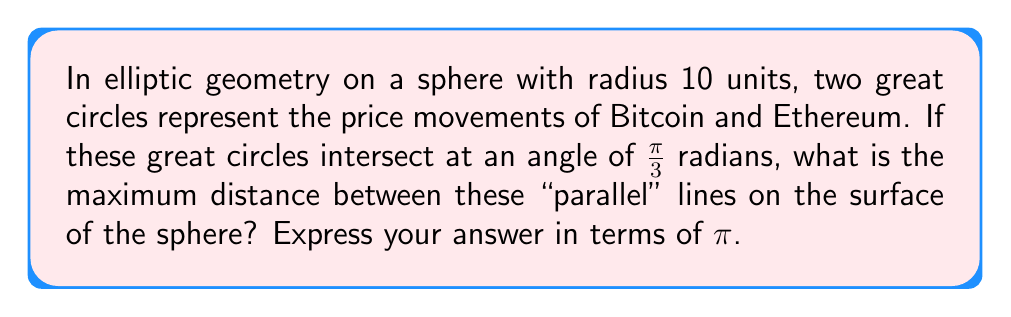Show me your answer to this math problem. Let's approach this step-by-step:

1) In elliptic geometry on a sphere, "parallel" lines are great circles that intersect at two antipodal points.

2) The maximum distance between two great circles occurs at the midpoint between their intersection points.

3) The angle between the great circles at their intersection is given as $\frac{\pi}{3}$ radians.

4) In spherical geometry, the distance $d$ between two points on a great circle is related to the central angle $\theta$ by the formula:

   $$d = r\theta$$

   where $r$ is the radius of the sphere.

5) The maximum distance occurs when the central angle is half of the angle between the great circles:

   $$\theta_{max} = \frac{1}{2} \cdot \frac{\pi}{3} = \frac{\pi}{6}$$

6) Now we can calculate the maximum distance:

   $$d_{max} = r\theta_{max} = 10 \cdot \frac{\pi}{6} = \frac{5\pi}{3}$$

7) Therefore, the maximum distance between the "parallel" lines representing Bitcoin and Ethereum price movements is $\frac{5\pi}{3}$ units on the surface of the sphere.
Answer: $\frac{5\pi}{3}$ units 